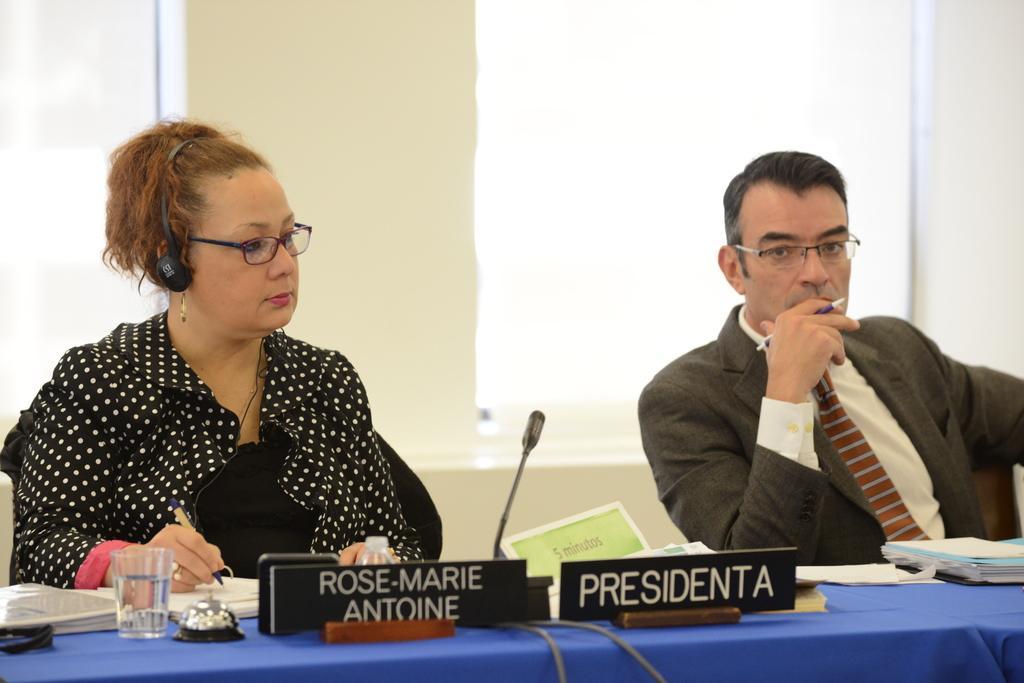In one or two sentences, can you explain what this image depicts? This is the picture in a room. The two people are siting on a chair. The man was siting in a position of thing and the man is holding a pen and beside the man there is a women and the women is in black dress the women is also holding a pen this are the name boards this is the table covered with blue cloth on the table there is a water glass and the papers and the files, background the two people there is a wall which is in white color and the windows, and the two persons were wearing the spectacles. 